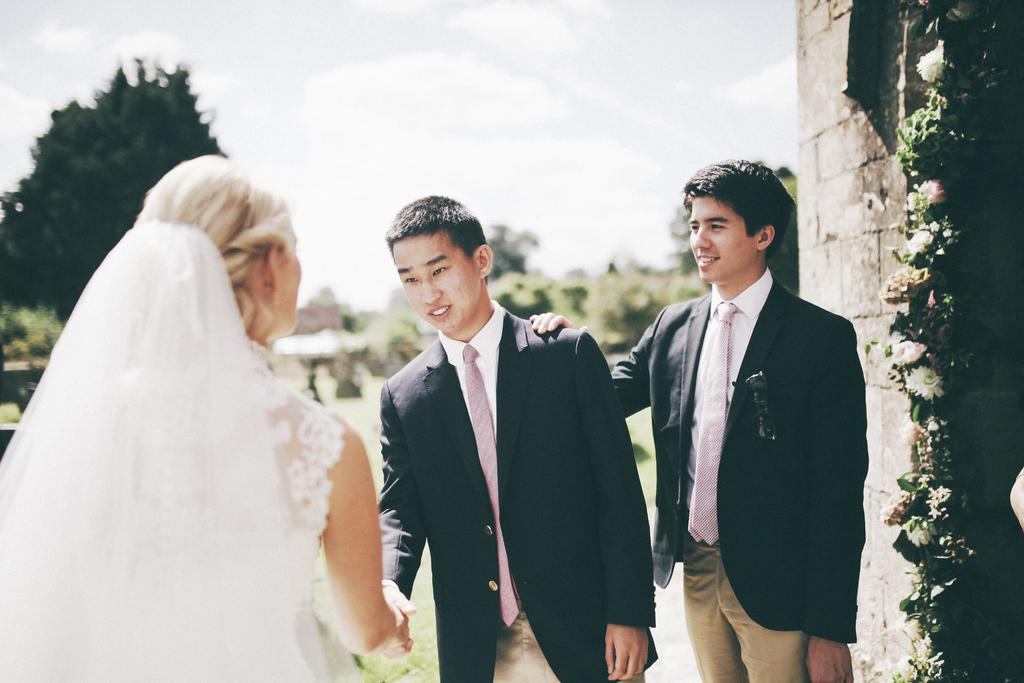How many people are present in the image? There are two men and a woman in the image. What is the woman wearing that is unique to her appearance? The woman is wearing a veil. What can be seen on the right side of the image? There is a wall with flower decorations on the right side of the image. What is visible in the background of the image? Trees and the sky are visible in the background of the image. What type of feather can be seen on the woman's hat in the image? There is no feather visible on the woman's hat in the image. What type of quilt is being used as a tablecloth in the image? There is no quilt present in the image. 